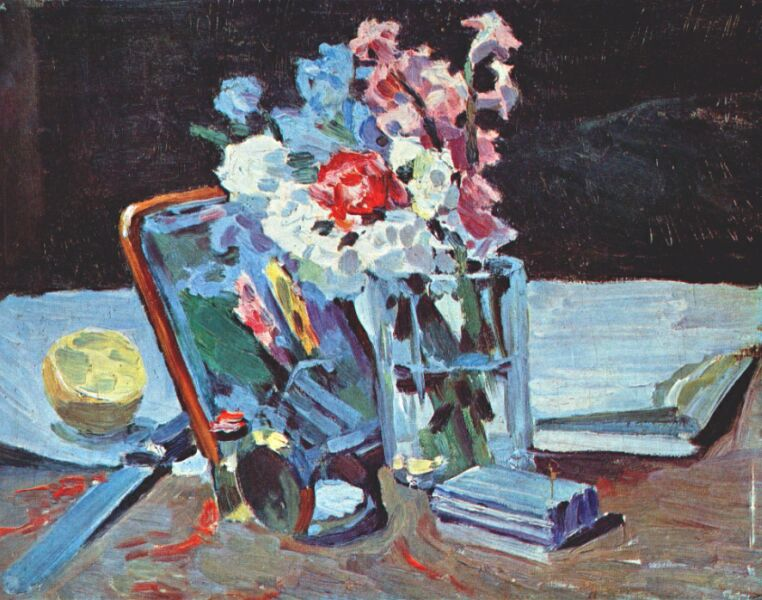Can you elaborate on the elements of the picture provided?
 The image is a captivating representation of an impressionist still life painting. The central focus is a vase brimming with flowers in hues of white, red, and pink, which is elegantly placed on a blue book. The table on which these items rest is draped with a dark cloth, creating a striking contrast with the vibrant colors of the objects. Scattered around the table are a variety of objects, including a playful yellow ball, another blue book, and an intriguing object striped in red and white. The background is shrouded in darkness, further accentuating the bold and vibrant colors of the objects in the foreground. The overall composition and use of color are characteristic of the impressionist art genre. 